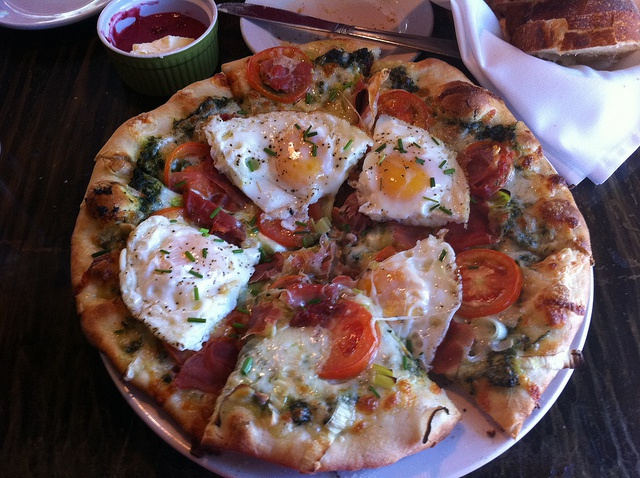Describe the objects in this image and their specific colors. I can see pizza in gray, maroon, darkgray, and black tones, dining table in gray, black, white, and purple tones, bowl in gray, black, maroon, lavender, and lightblue tones, and knife in gray, black, maroon, and purple tones in this image. 